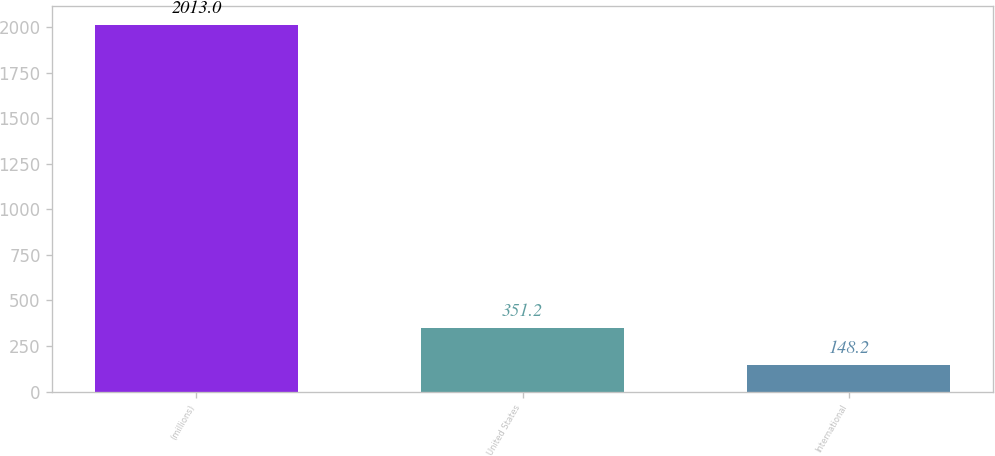<chart> <loc_0><loc_0><loc_500><loc_500><bar_chart><fcel>(millions)<fcel>United States<fcel>International<nl><fcel>2013<fcel>351.2<fcel>148.2<nl></chart> 